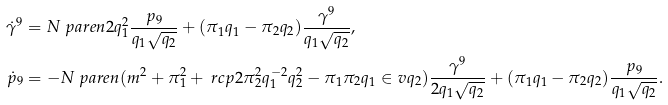Convert formula to latex. <formula><loc_0><loc_0><loc_500><loc_500>\dot { \gamma } ^ { 9 } & = N \ p a r e n { 2 q _ { 1 } ^ { 2 } \frac { p _ { 9 } } { q _ { 1 } \sqrt { q _ { 2 } } } + ( \pi _ { 1 } q _ { 1 } - \pi _ { 2 } q _ { 2 } ) \frac { \gamma ^ { 9 } } { q _ { 1 } \sqrt { q _ { 2 } } } } , \\ \dot { p } _ { 9 } & = - N \ p a r e n { ( m ^ { 2 } + \pi _ { 1 } ^ { 2 } + \ r c p 2 \pi _ { 2 } ^ { 2 } q _ { 1 } ^ { - 2 } q _ { 2 } ^ { 2 } - \pi _ { 1 } \pi _ { 2 } q _ { 1 } \in v q _ { 2 } ) \frac { \gamma ^ { 9 } } { 2 q _ { 1 } \sqrt { q _ { 2 } } } + ( \pi _ { 1 } q _ { 1 } - \pi _ { 2 } q _ { 2 } ) \frac { p _ { 9 } } { q _ { 1 } \sqrt { q _ { 2 } } } } .</formula> 